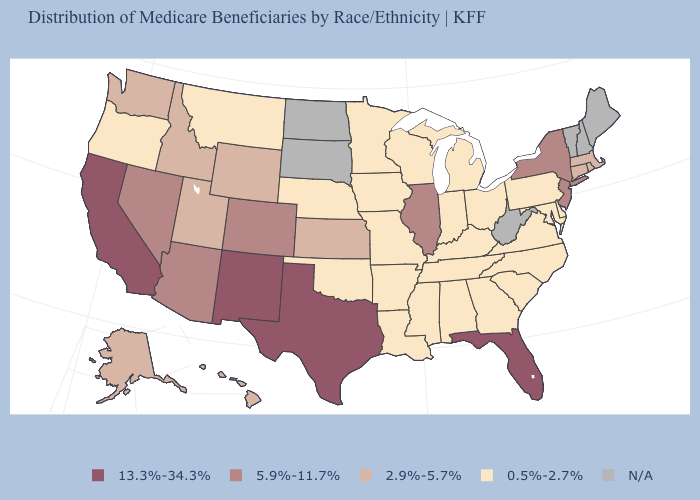Is the legend a continuous bar?
Be succinct. No. How many symbols are there in the legend?
Answer briefly. 5. Which states have the highest value in the USA?
Quick response, please. California, Florida, New Mexico, Texas. What is the value of Oklahoma?
Be succinct. 0.5%-2.7%. Name the states that have a value in the range 13.3%-34.3%?
Quick response, please. California, Florida, New Mexico, Texas. Name the states that have a value in the range 13.3%-34.3%?
Keep it brief. California, Florida, New Mexico, Texas. How many symbols are there in the legend?
Be succinct. 5. Name the states that have a value in the range 5.9%-11.7%?
Be succinct. Arizona, Colorado, Illinois, Nevada, New Jersey, New York. What is the highest value in the USA?
Be succinct. 13.3%-34.3%. What is the value of Oklahoma?
Give a very brief answer. 0.5%-2.7%. Name the states that have a value in the range 5.9%-11.7%?
Quick response, please. Arizona, Colorado, Illinois, Nevada, New Jersey, New York. Among the states that border Illinois , which have the highest value?
Write a very short answer. Indiana, Iowa, Kentucky, Missouri, Wisconsin. Which states hav the highest value in the South?
Be succinct. Florida, Texas. 